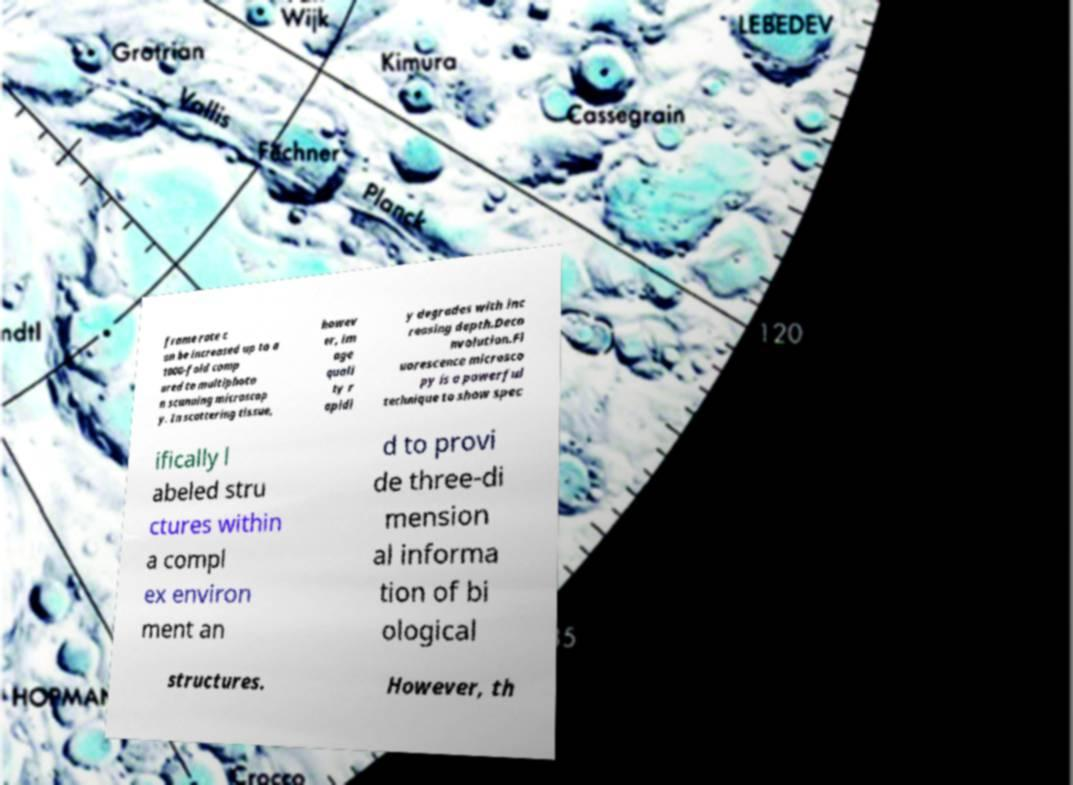There's text embedded in this image that I need extracted. Can you transcribe it verbatim? frame rate c an be increased up to a 1000-fold comp ared to multiphoto n scanning microscop y. In scattering tissue, howev er, im age quali ty r apidl y degrades with inc reasing depth.Deco nvolution.Fl uorescence microsco py is a powerful technique to show spec ifically l abeled stru ctures within a compl ex environ ment an d to provi de three-di mension al informa tion of bi ological structures. However, th 